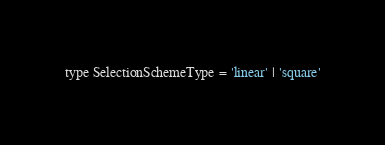<code> <loc_0><loc_0><loc_500><loc_500><_JavaScript_>
type SelectionSchemeType = 'linear' | 'square'</code> 